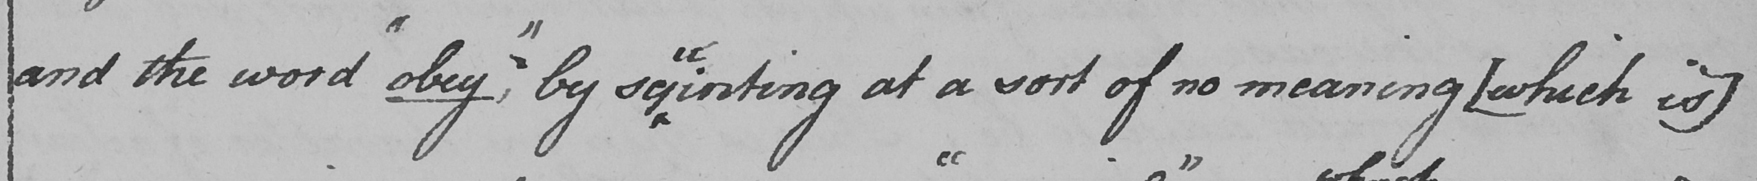What does this handwritten line say? and the word  " obey , "  by sq inting at a sort of no meaning  [ which is ] 